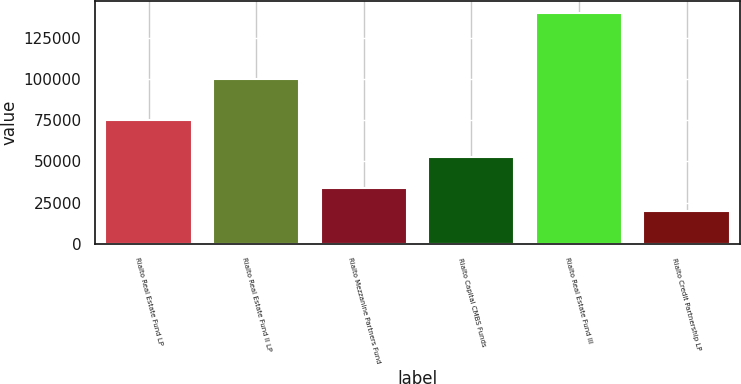Convert chart to OTSL. <chart><loc_0><loc_0><loc_500><loc_500><bar_chart><fcel>Rialto Real Estate Fund LP<fcel>Rialto Real Estate Fund II LP<fcel>Rialto Mezzanine Partners Fund<fcel>Rialto Capital CMBS Funds<fcel>Rialto Real Estate Fund III<fcel>Rialto Credit Partnership LP<nl><fcel>75000<fcel>100000<fcel>33799<fcel>52474<fcel>140000<fcel>19999<nl></chart> 